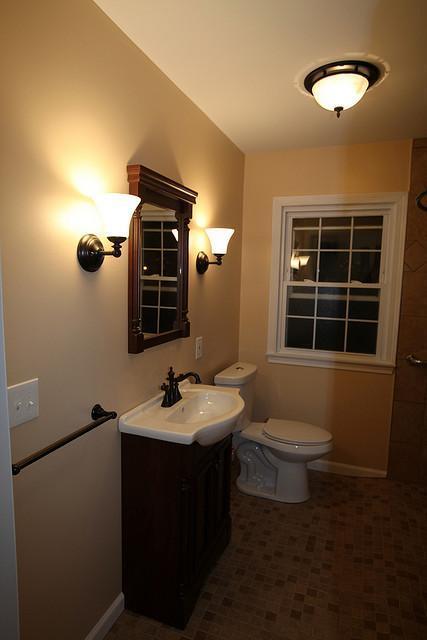How many lights are on?
Give a very brief answer. 3. 